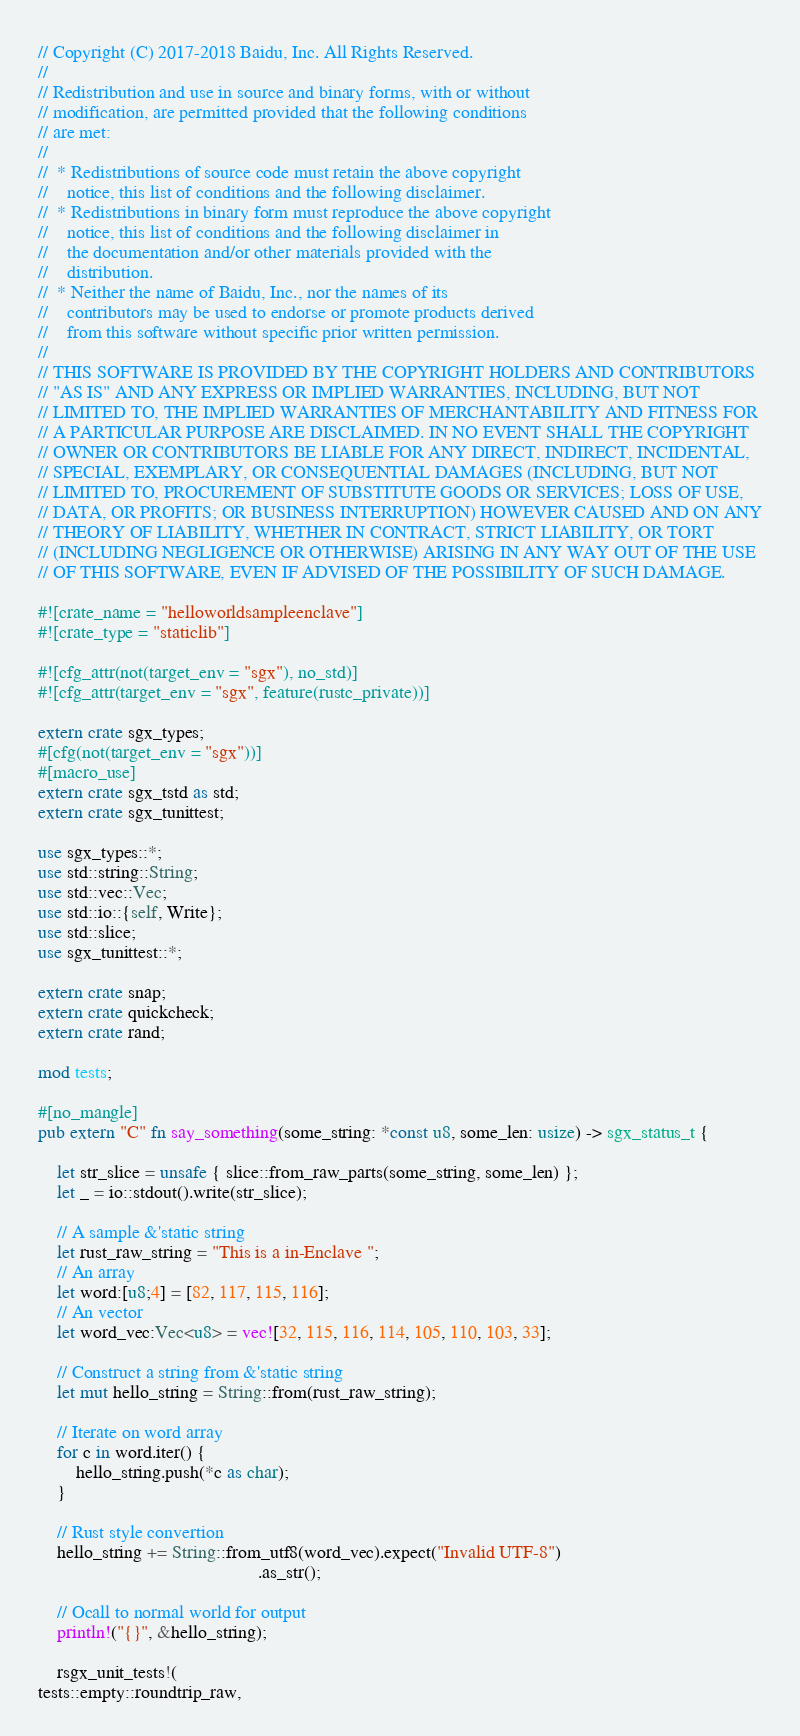Convert code to text. <code><loc_0><loc_0><loc_500><loc_500><_Rust_>// Copyright (C) 2017-2018 Baidu, Inc. All Rights Reserved.
//
// Redistribution and use in source and binary forms, with or without
// modification, are permitted provided that the following conditions
// are met:
//
//  * Redistributions of source code must retain the above copyright
//    notice, this list of conditions and the following disclaimer.
//  * Redistributions in binary form must reproduce the above copyright
//    notice, this list of conditions and the following disclaimer in
//    the documentation and/or other materials provided with the
//    distribution.
//  * Neither the name of Baidu, Inc., nor the names of its
//    contributors may be used to endorse or promote products derived
//    from this software without specific prior written permission.
//
// THIS SOFTWARE IS PROVIDED BY THE COPYRIGHT HOLDERS AND CONTRIBUTORS
// "AS IS" AND ANY EXPRESS OR IMPLIED WARRANTIES, INCLUDING, BUT NOT
// LIMITED TO, THE IMPLIED WARRANTIES OF MERCHANTABILITY AND FITNESS FOR
// A PARTICULAR PURPOSE ARE DISCLAIMED. IN NO EVENT SHALL THE COPYRIGHT
// OWNER OR CONTRIBUTORS BE LIABLE FOR ANY DIRECT, INDIRECT, INCIDENTAL,
// SPECIAL, EXEMPLARY, OR CONSEQUENTIAL DAMAGES (INCLUDING, BUT NOT
// LIMITED TO, PROCUREMENT OF SUBSTITUTE GOODS OR SERVICES; LOSS OF USE,
// DATA, OR PROFITS; OR BUSINESS INTERRUPTION) HOWEVER CAUSED AND ON ANY
// THEORY OF LIABILITY, WHETHER IN CONTRACT, STRICT LIABILITY, OR TORT
// (INCLUDING NEGLIGENCE OR OTHERWISE) ARISING IN ANY WAY OUT OF THE USE
// OF THIS SOFTWARE, EVEN IF ADVISED OF THE POSSIBILITY OF SUCH DAMAGE.

#![crate_name = "helloworldsampleenclave"]
#![crate_type = "staticlib"]

#![cfg_attr(not(target_env = "sgx"), no_std)]
#![cfg_attr(target_env = "sgx", feature(rustc_private))]

extern crate sgx_types;
#[cfg(not(target_env = "sgx"))]
#[macro_use]
extern crate sgx_tstd as std;
extern crate sgx_tunittest;

use sgx_types::*;
use std::string::String;
use std::vec::Vec;
use std::io::{self, Write};
use std::slice;
use sgx_tunittest::*;

extern crate snap;
extern crate quickcheck;
extern crate rand;

mod tests;

#[no_mangle]
pub extern "C" fn say_something(some_string: *const u8, some_len: usize) -> sgx_status_t {

    let str_slice = unsafe { slice::from_raw_parts(some_string, some_len) };
    let _ = io::stdout().write(str_slice);

    // A sample &'static string
    let rust_raw_string = "This is a in-Enclave ";
    // An array
    let word:[u8;4] = [82, 117, 115, 116];
    // An vector
    let word_vec:Vec<u8> = vec![32, 115, 116, 114, 105, 110, 103, 33];

    // Construct a string from &'static string
    let mut hello_string = String::from(rust_raw_string);

    // Iterate on word array
    for c in word.iter() {
        hello_string.push(*c as char);
    }

    // Rust style convertion
    hello_string += String::from_utf8(word_vec).expect("Invalid UTF-8")
                                               .as_str();

    // Ocall to normal world for output
    println!("{}", &hello_string);

    rsgx_unit_tests!(
tests::empty::roundtrip_raw,</code> 